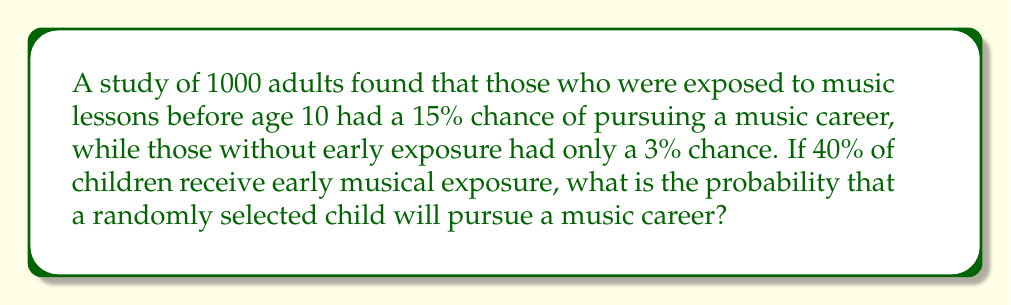What is the answer to this math problem? Let's approach this step-by-step:

1) Define events:
   E: Early musical exposure
   M: Pursues a music career

2) Given probabilities:
   $P(E) = 0.40$ (40% receive early exposure)
   $P(M|E) = 0.15$ (15% chance of music career with early exposure)
   $P(M|\text{not }E) = 0.03$ (3% chance without early exposure)

3) Use the law of total probability:
   $P(M) = P(M|E) \cdot P(E) + P(M|\text{not }E) \cdot P(\text{not }E)$

4) Calculate $P(\text{not }E)$:
   $P(\text{not }E) = 1 - P(E) = 1 - 0.40 = 0.60$

5) Substitute into the formula:
   $P(M) = 0.15 \cdot 0.40 + 0.03 \cdot 0.60$

6) Calculate:
   $P(M) = 0.06 + 0.018 = 0.078$

7) Convert to percentage:
   $0.078 \cdot 100\% = 7.8\%$
Answer: 7.8% 